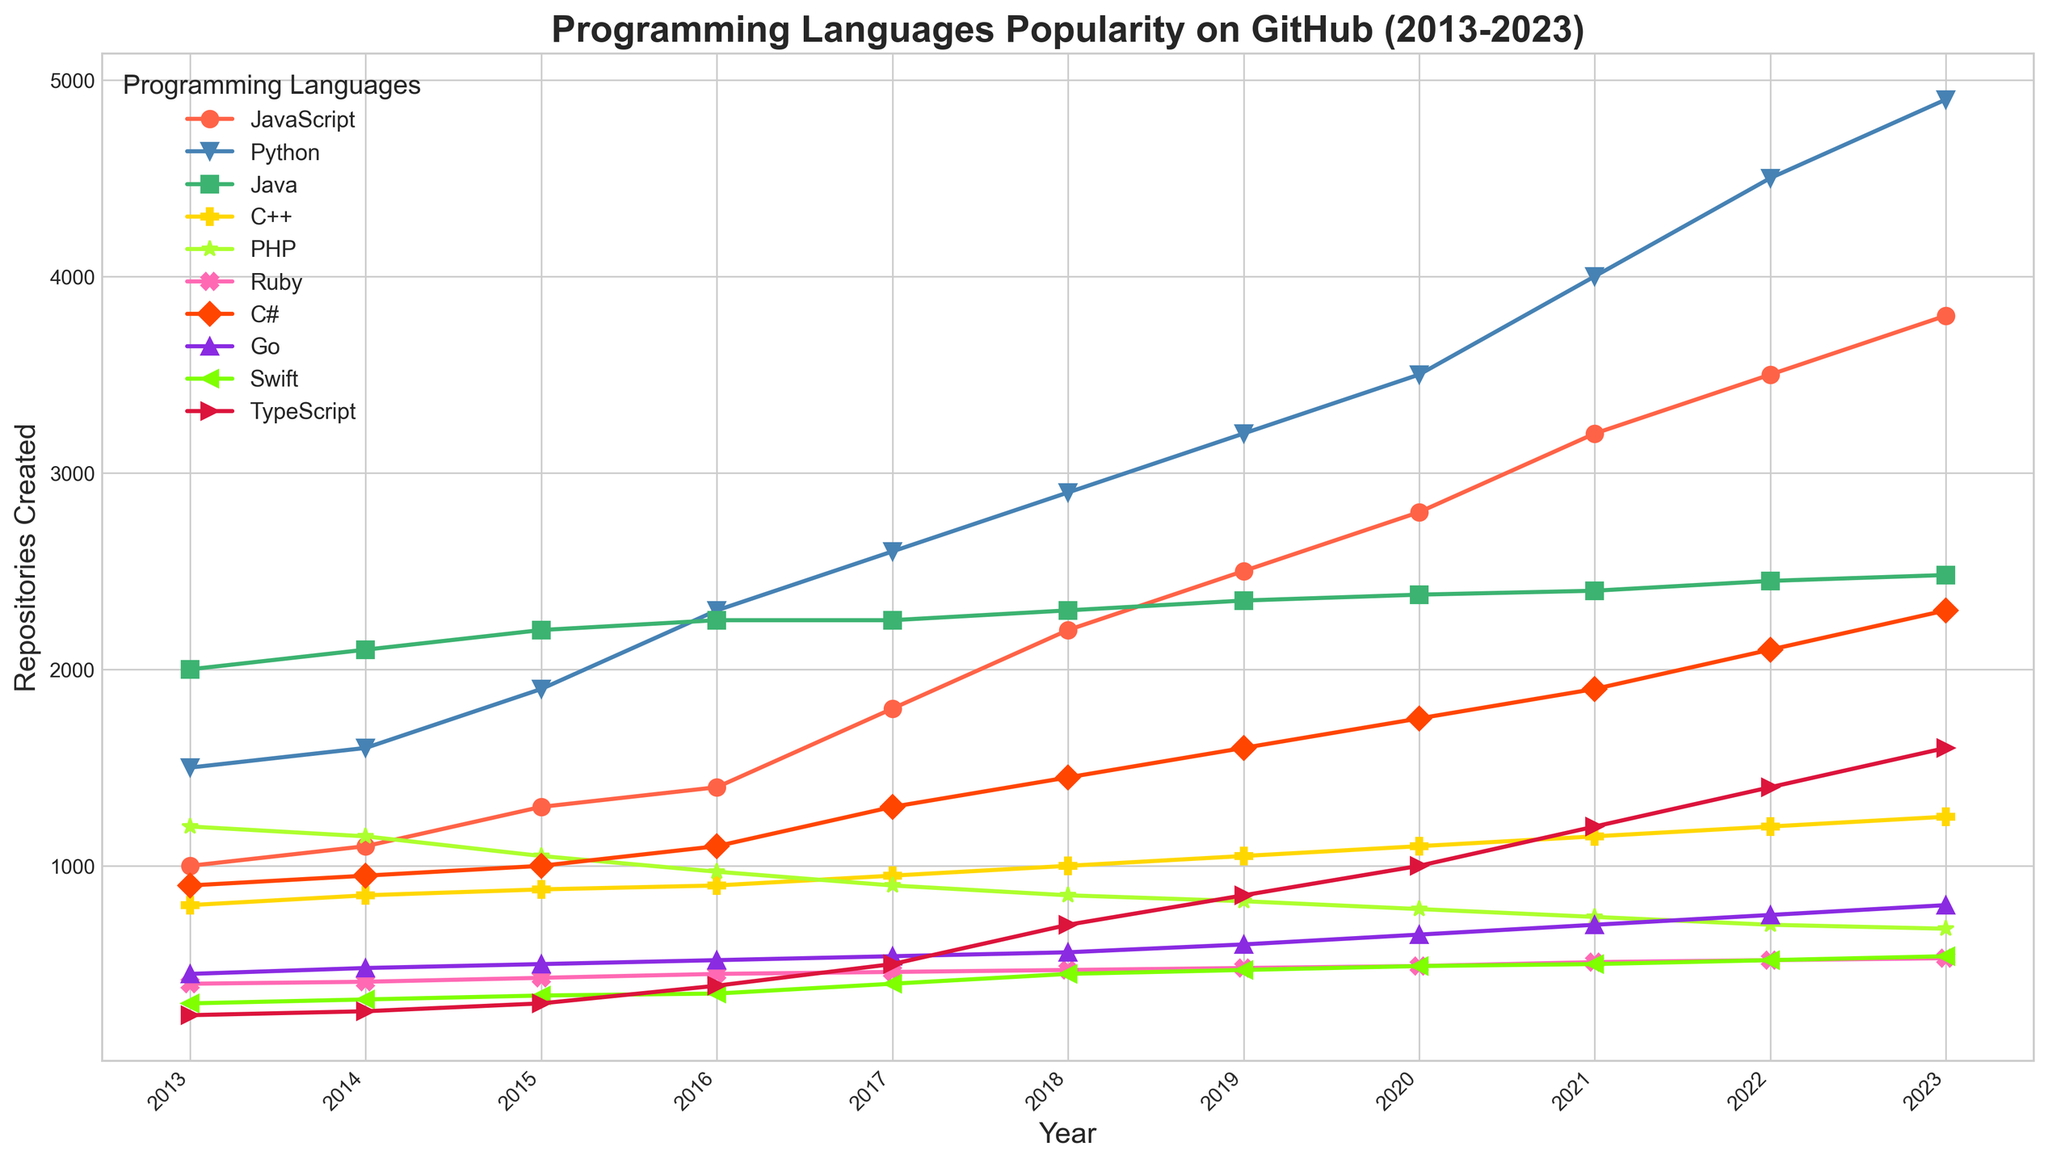Which programming language had the highest number of repositories created in 2023? By looking at the end of each line in the figure for 2023, we can observe the vertical positions of the markers. The line for Python is at the highest point in 2023.
Answer: Python Compare the trend of repository creation between JavaScript and Ruby over the years. Which one shows a higher growth rate? To determine the growth rate, note the starting and ending points of both languages over the years. JavaScript starts at 1000 in 2013 and ends at 3800 in 2023. Ruby starts at 900 in 2013 and ends at 2300 in 2023. The difference for JavaScript is 2800 (3800-1000), and for Ruby, it is 1400 (2300-900). Hence, JavaScript shows a higher growth rate.
Answer: JavaScript Which language experienced the biggest drop in repositories between any two consecutive years? By examining the plot for sudden drops, PHP shows a steep decline from 1200 in 2013 to 1150 in 2014. The drop is 50. Checking other languages confirms no other significant drops between consecutive years.
Answer: PHP If you add the number of repositories created for Go and Swift in 2023, what is the total? From the figure, locate the data points for Go and Swift in 2023. Go has 800 and Swift has 540 repositories. Adding them gives 800 + 540 = 1340.
Answer: 1340 How did the popularity of TypeScript compare to C++ in 2020? In the figure for 2020, check the heights of the markers for TypeScript and C++. TypeScript is at 1000, while C++ is at 1100. Hence, C++ had slightly more repositories created than TypeScript in 2020.
Answer: C++ Which year shows the most significant increase in Python repositories from the previous year? Compare the distance between adjacent Python points for each consecutive year. The gap is largest between 2021 (4000) and 2022 (4500), an increase of 500 repositories.
Answer: 2022 